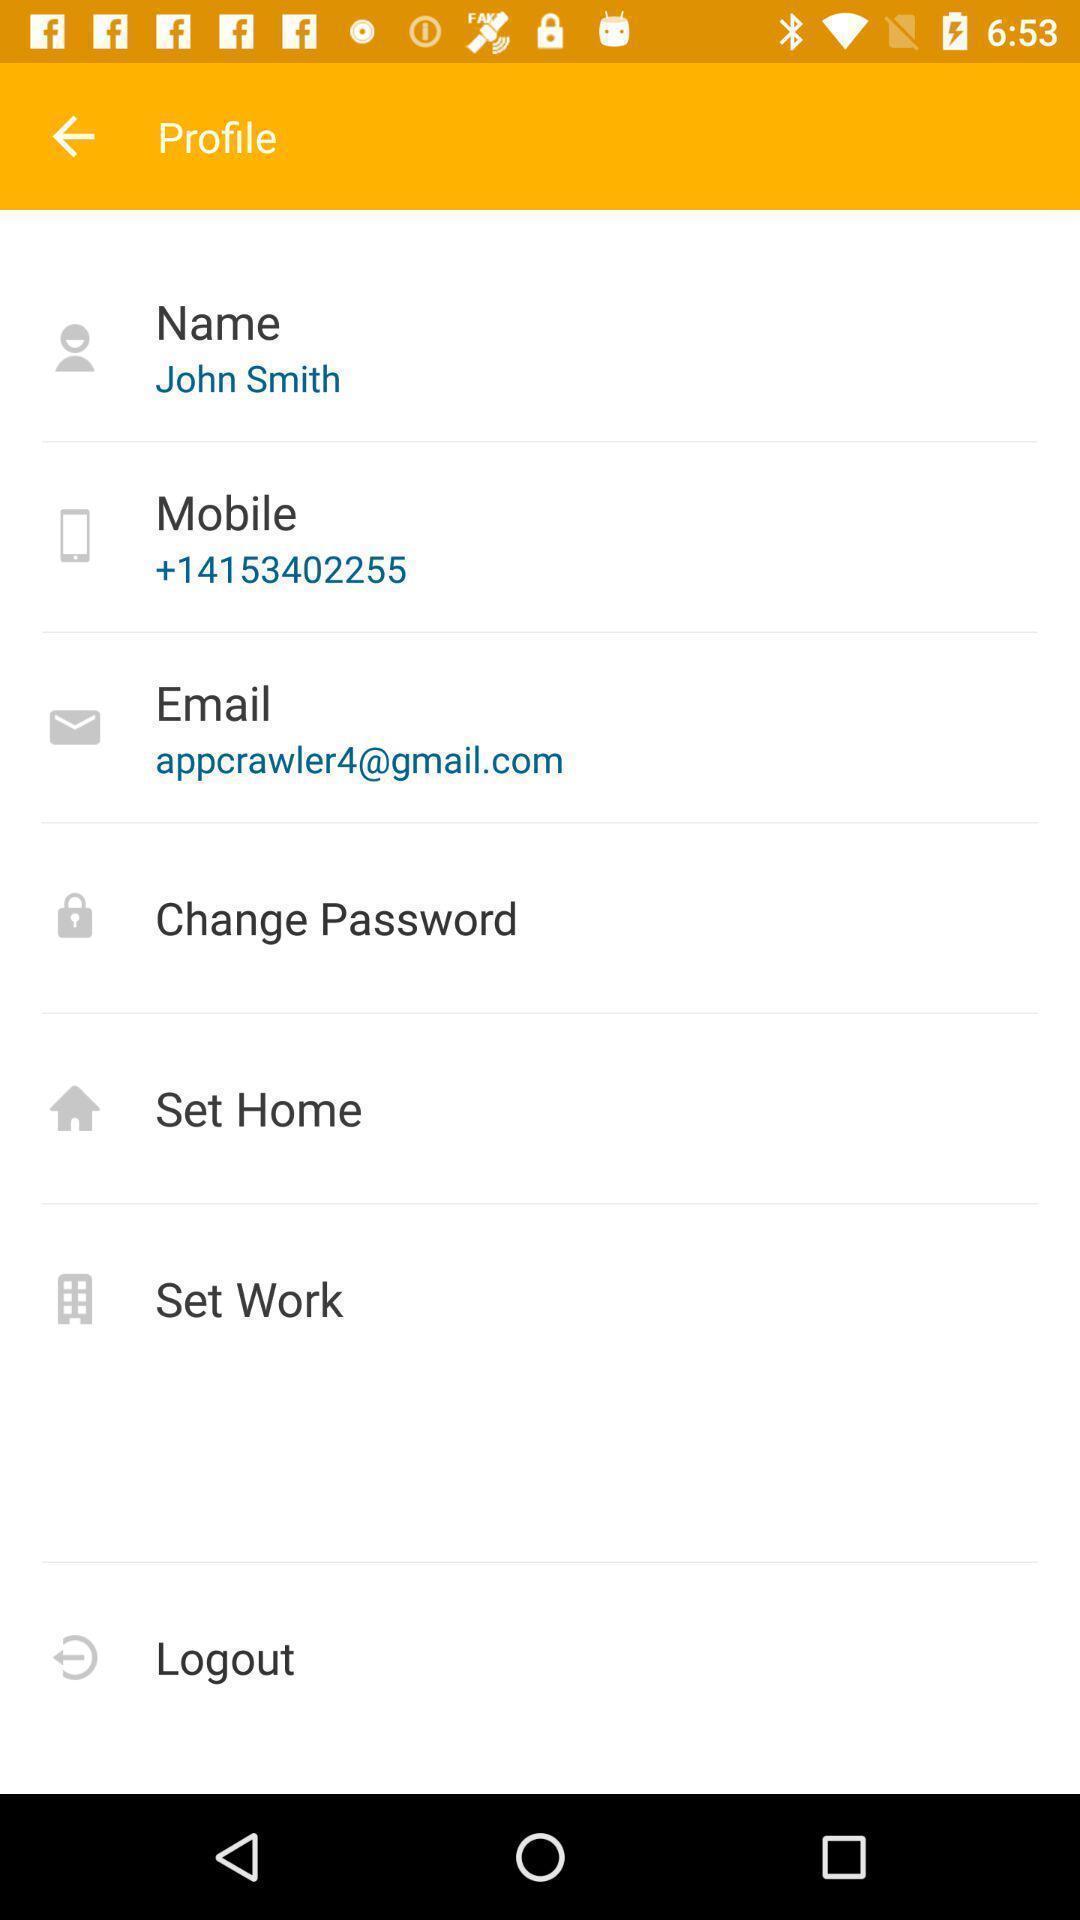Please provide a description for this image. Page displaying the profile details. 